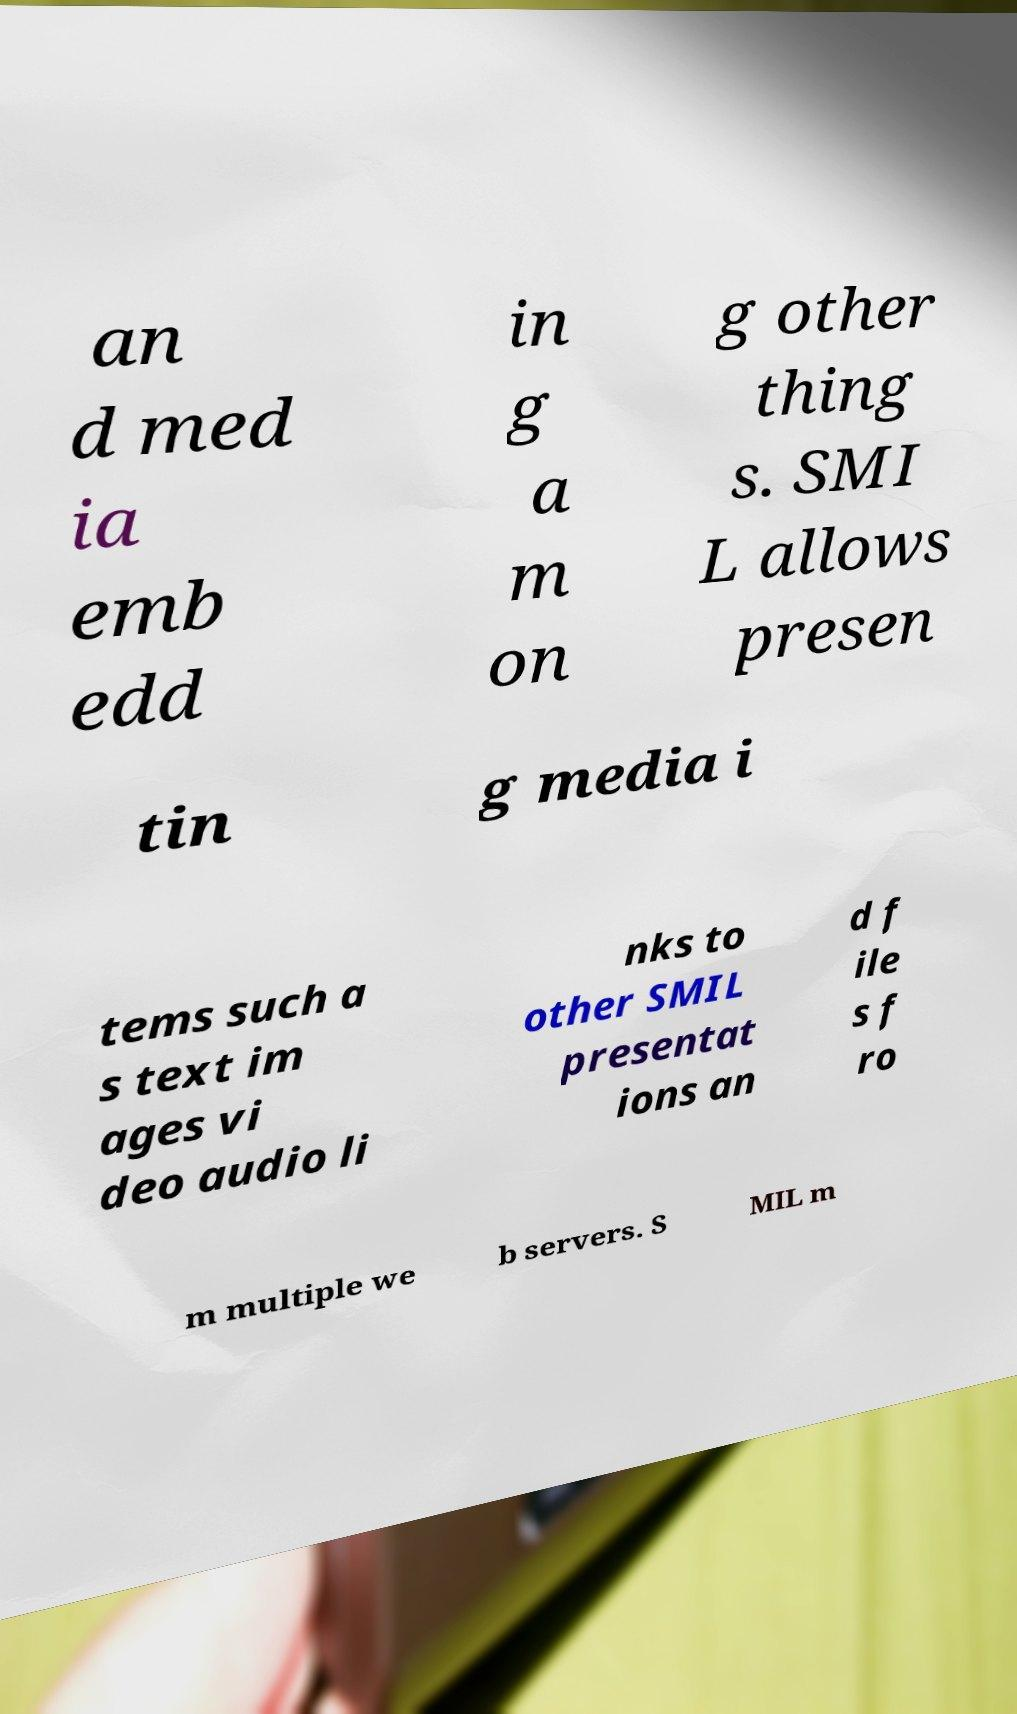Please read and relay the text visible in this image. What does it say? an d med ia emb edd in g a m on g other thing s. SMI L allows presen tin g media i tems such a s text im ages vi deo audio li nks to other SMIL presentat ions an d f ile s f ro m multiple we b servers. S MIL m 